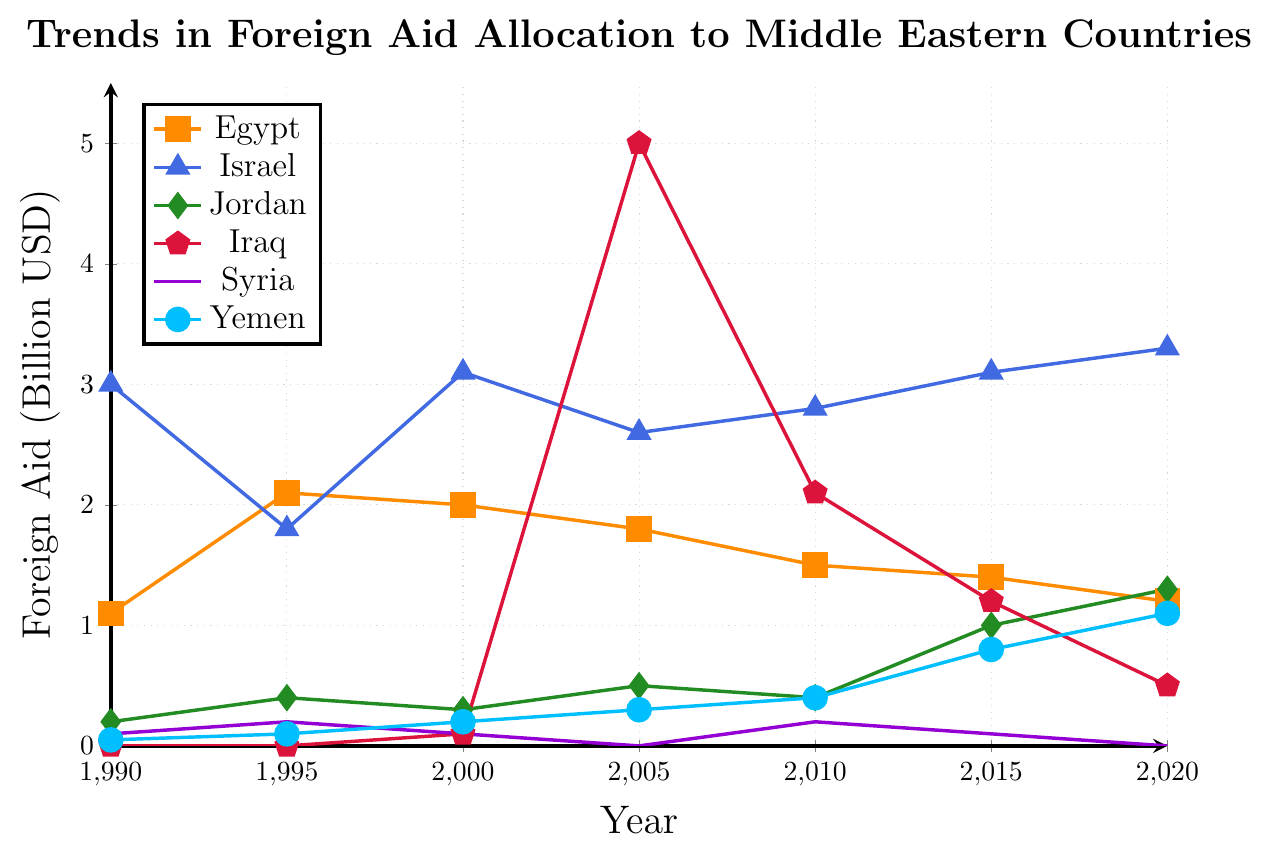What is the trend in foreign aid to Iraq from 2000 to 2020? Between 2000 and 2005, foreign aid to Iraq drastically increased from 0.1 billion USD to 5.0 billion USD. It then decreased significantly to 2.1 billion USD in 2010, further dropped to 1.2 billion USD in 2015, and continued declining to 0.5 billion USD in 2020.
Answer: Aid increased from 2000 to 2005, then continuously decreased until 2020 Which country received the highest amount of aid in 2005? By examining the plot for the year 2005, Iraq received the highest amount of foreign aid, with 5.0 billion USD.
Answer: Iraq How did the foreign aid to Israel change between 1995 and 2000? From 1995 to 2000, foreign aid to Israel increased from 1.8 billion USD to 3.1 billion USD.
Answer: It increased Which country had the lowest amount of foreign aid in 1990? The plot shows Yemen received the least foreign aid in 1990, with 0.05 billion USD.
Answer: Yemen What is the overall trend in foreign aid to Egypt from 1995 to 2020? Foreign aid to Egypt peaked in 1995 at 2.1 billion USD, then gradually decreased over the years to 1.2 billion USD in 2020.
Answer: Decreasing Compare the trend of aid to Jordan with Yemen from 2010 onwards. From 2010, both Jordan and Yemen have increasing trends in foreign aid. Jordan increased from 0.4 billion USD in 2010 to 1.3 billion USD in 2020. Yemen increased from 0.4 billion USD in 2010 to 1.1 billion USD in 2020.
Answer: Both increased, Jordan slightly more In which year did Syria receive the maximum aid? By looking at the plot, Syria received the maximum aid in 1995, with 0.2 billion USD.
Answer: 1995 Calculate the average annual aid to Jordan from 1990 to 2020. First, add the yearly aid values: 0.2 + 0.4 + 0.3 + 0.5 + 0.4 + 1.0 + 1.3 = 4.1. There are 7 data points, so the average is 4.1 / 7 = 0.586 billion USD.
Answer: 0.586 billion USD What significant event possibly influenced the high aid to Iraq in 2005? The substantial increase in aid to Iraq in 2005 likely corresponds to the post-2003 Iraq War reconstruction efforts, leading to increased foreign aid to rebuild the country.
Answer: Post Iraq War reconstruction Which country saw a consistent increase in aid from 1990 to 2020? Yemen shows a consistent increase in foreign aid from 0.05 billion USD in 1990 to 1.1 billion USD in 2020.
Answer: Yemen 